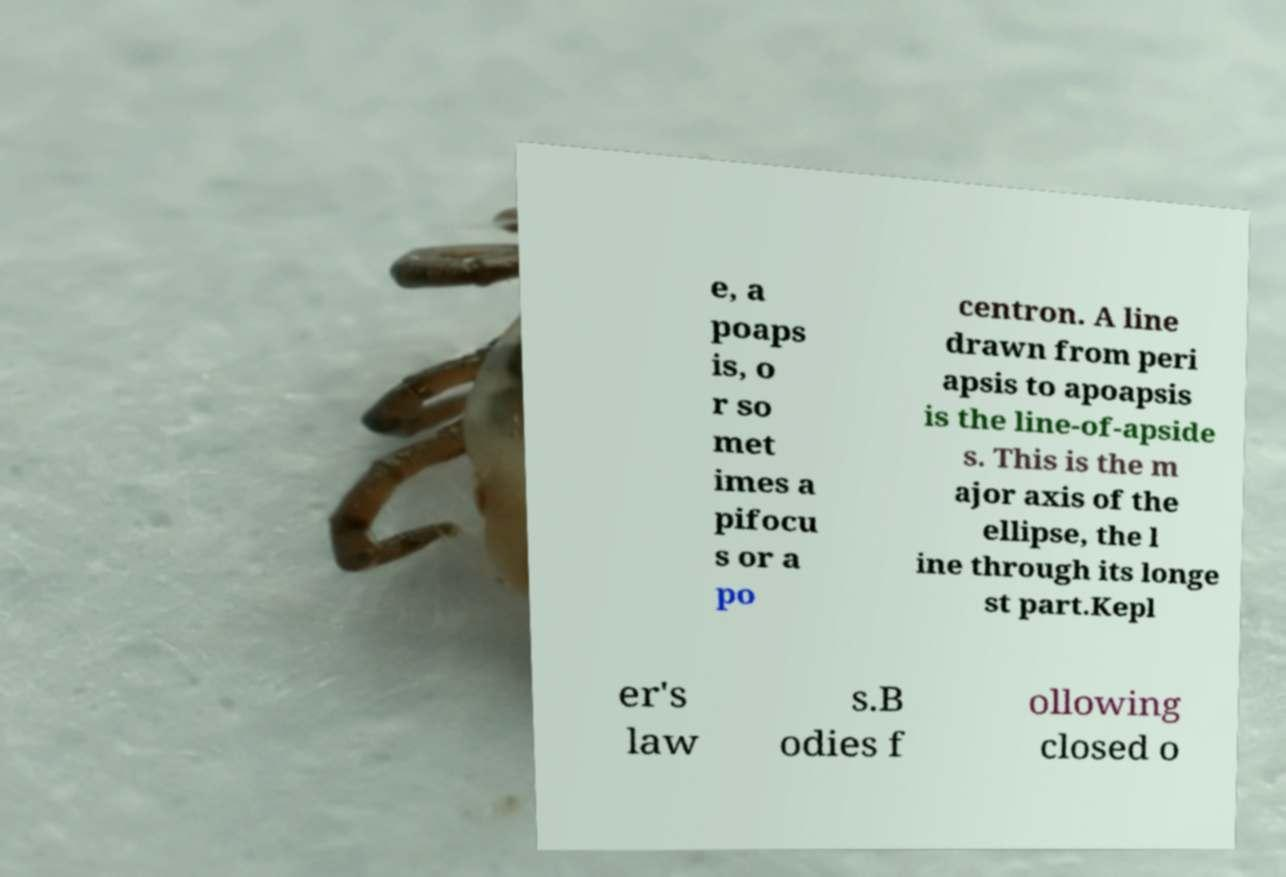Please read and relay the text visible in this image. What does it say? e, a poaps is, o r so met imes a pifocu s or a po centron. A line drawn from peri apsis to apoapsis is the line-of-apside s. This is the m ajor axis of the ellipse, the l ine through its longe st part.Kepl er's law s.B odies f ollowing closed o 